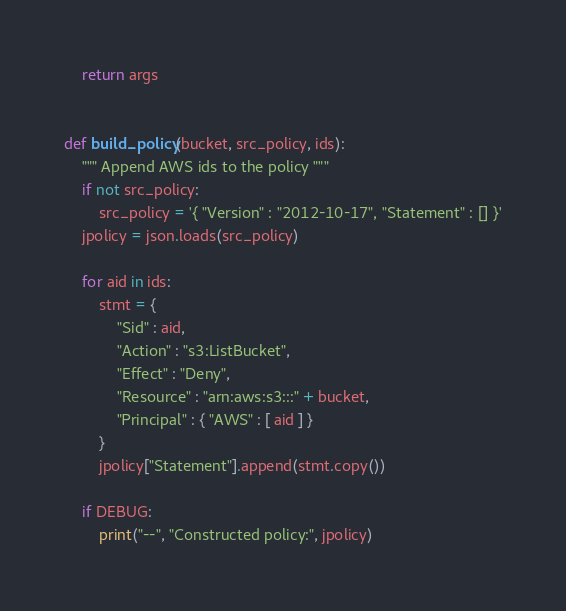<code> <loc_0><loc_0><loc_500><loc_500><_Python_>    return args


def build_policy(bucket, src_policy, ids):
    """ Append AWS ids to the policy """
    if not src_policy:
        src_policy = '{ "Version" : "2012-10-17", "Statement" : [] }'
    jpolicy = json.loads(src_policy)

    for aid in ids:
        stmt = {
            "Sid" : aid,
            "Action" : "s3:ListBucket",
            "Effect" : "Deny",
            "Resource" : "arn:aws:s3:::" + bucket,
            "Principal" : { "AWS" : [ aid ] }
        }
        jpolicy["Statement"].append(stmt.copy())

    if DEBUG:
        print("--", "Constructed policy:", jpolicy)
</code> 